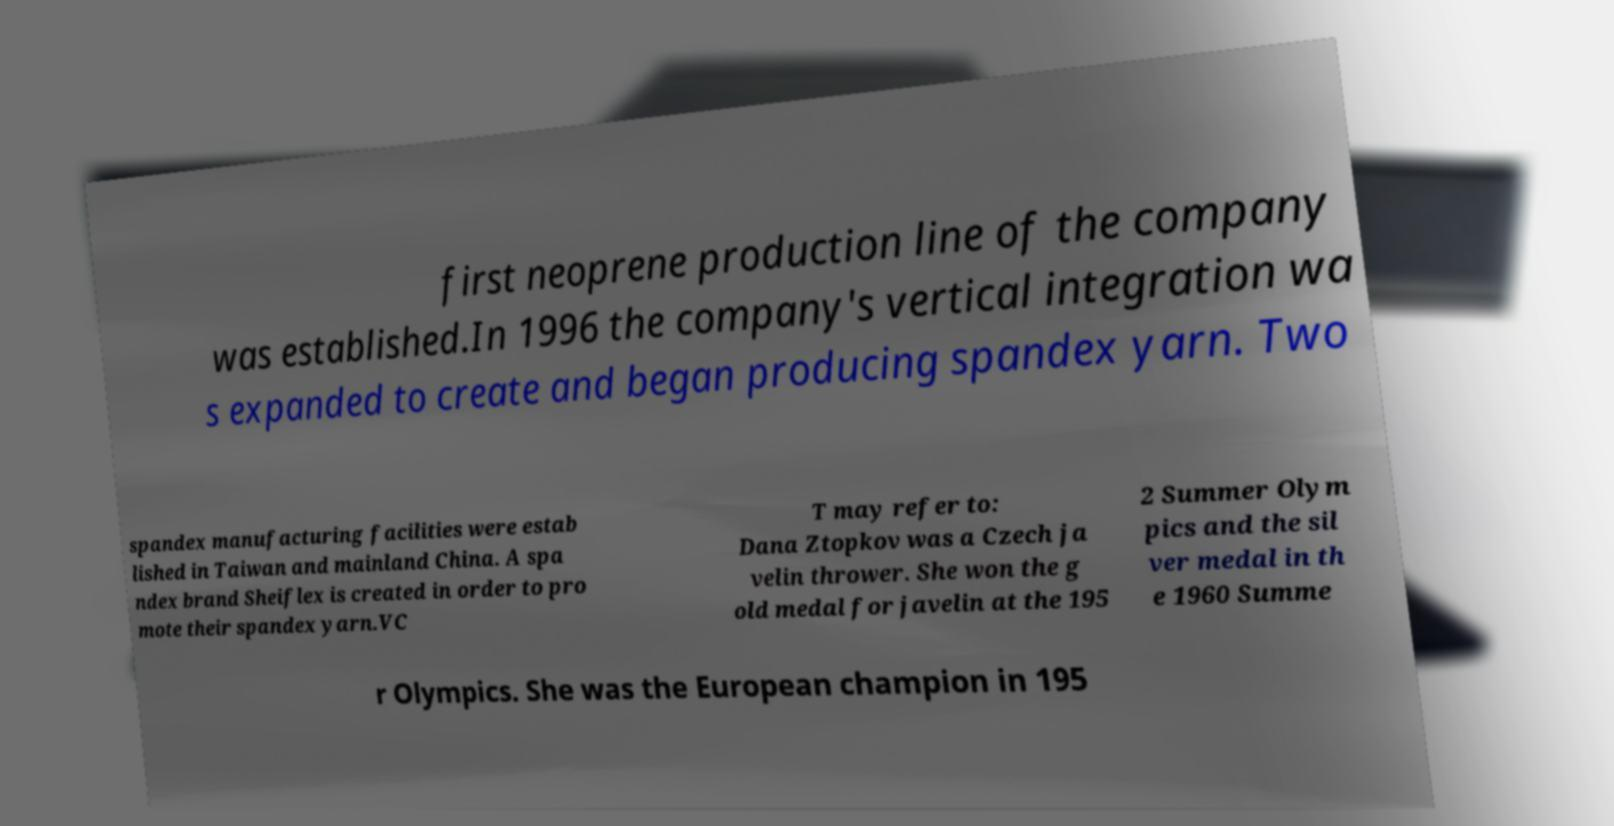Please read and relay the text visible in this image. What does it say? first neoprene production line of the company was established.In 1996 the company's vertical integration wa s expanded to create and began producing spandex yarn. Two spandex manufacturing facilities were estab lished in Taiwan and mainland China. A spa ndex brand Sheiflex is created in order to pro mote their spandex yarn.VC T may refer to: Dana Ztopkov was a Czech ja velin thrower. She won the g old medal for javelin at the 195 2 Summer Olym pics and the sil ver medal in th e 1960 Summe r Olympics. She was the European champion in 195 